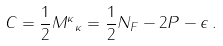Convert formula to latex. <formula><loc_0><loc_0><loc_500><loc_500>C = \frac { 1 } { 2 } { M ^ { \kappa } } _ { \kappa } = \frac { 1 } { 2 } N _ { F } - 2 P - \epsilon \, .</formula> 